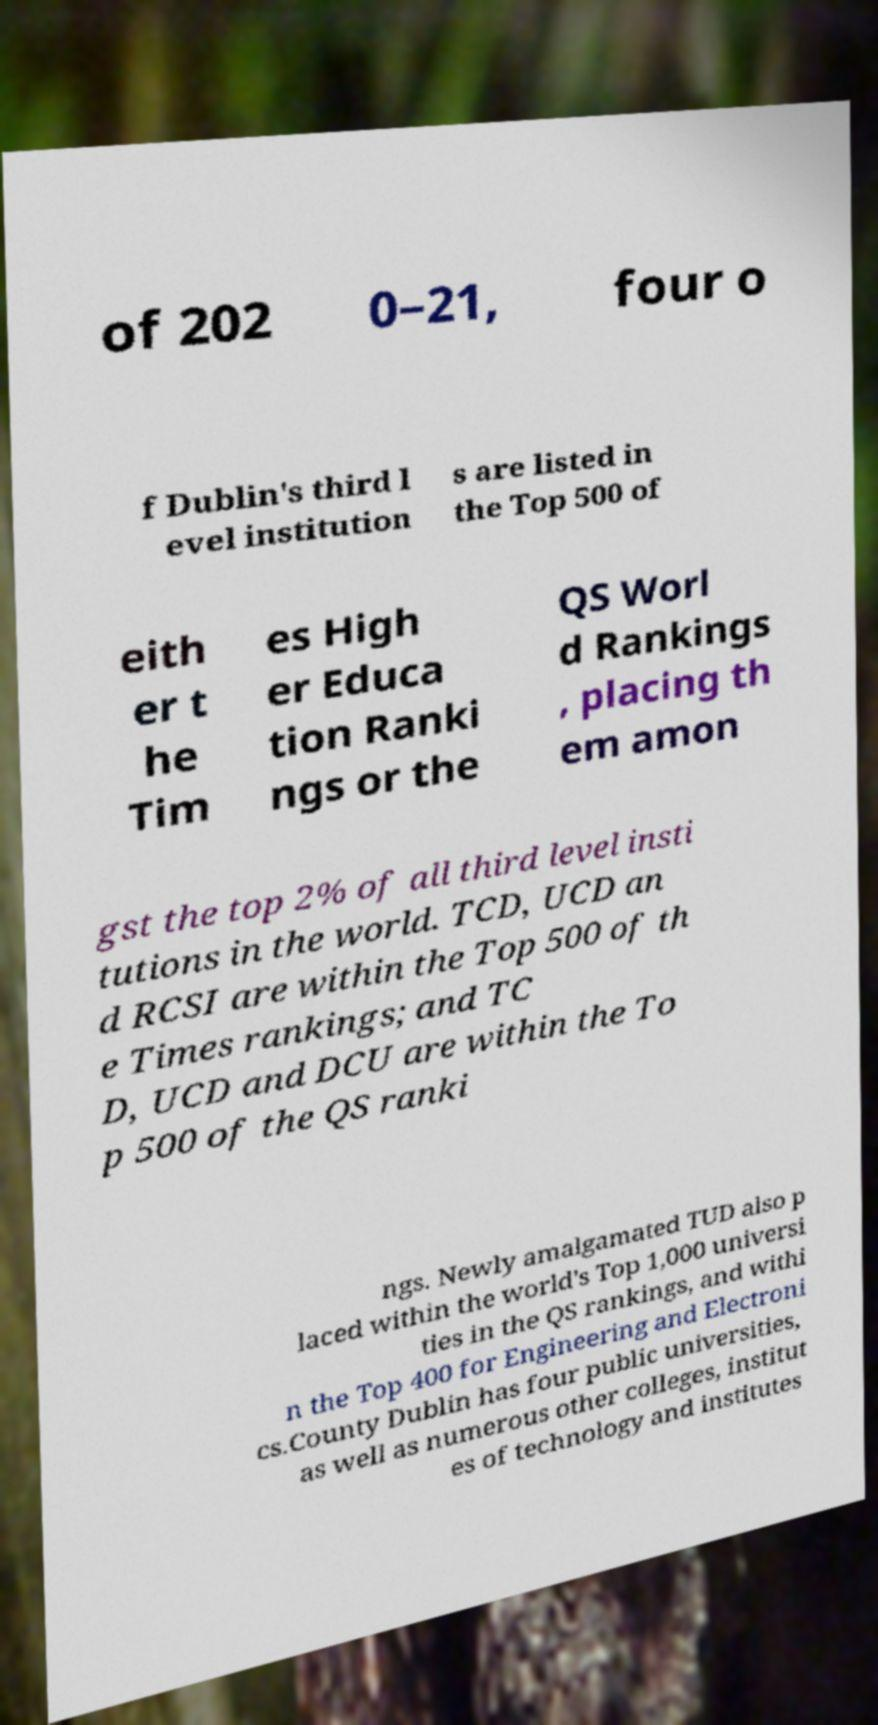Please identify and transcribe the text found in this image. of 202 0–21, four o f Dublin's third l evel institution s are listed in the Top 500 of eith er t he Tim es High er Educa tion Ranki ngs or the QS Worl d Rankings , placing th em amon gst the top 2% of all third level insti tutions in the world. TCD, UCD an d RCSI are within the Top 500 of th e Times rankings; and TC D, UCD and DCU are within the To p 500 of the QS ranki ngs. Newly amalgamated TUD also p laced within the world's Top 1,000 universi ties in the QS rankings, and withi n the Top 400 for Engineering and Electroni cs.County Dublin has four public universities, as well as numerous other colleges, institut es of technology and institutes 